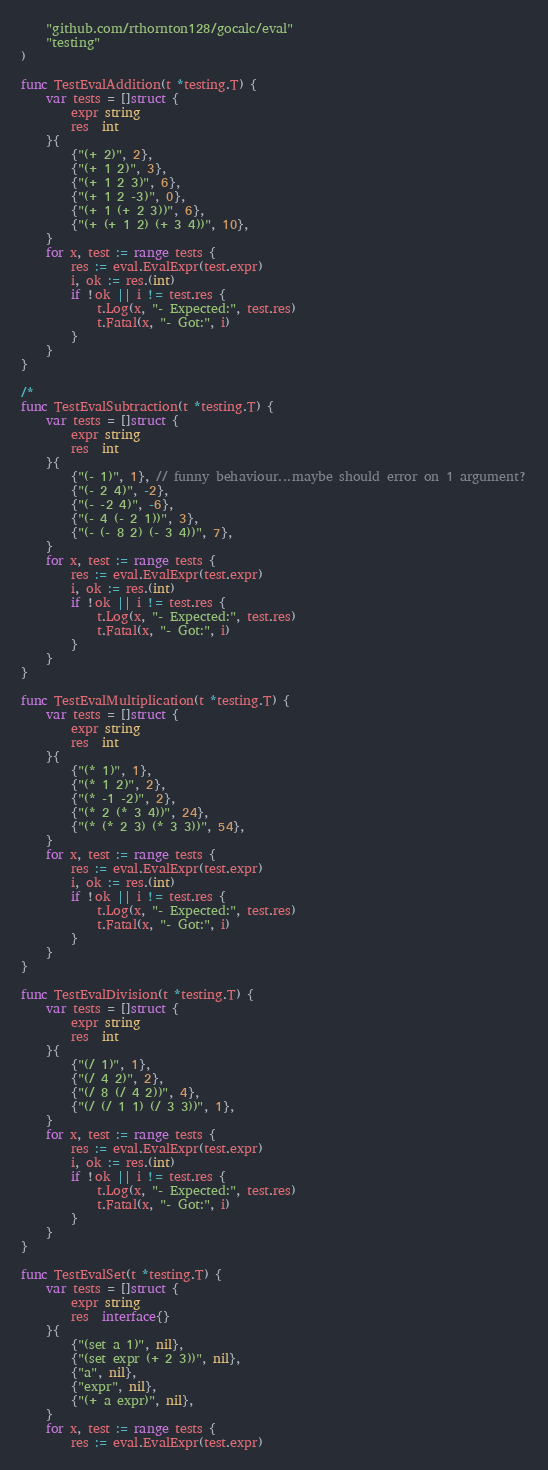<code> <loc_0><loc_0><loc_500><loc_500><_Go_>	"github.com/rthornton128/gocalc/eval"
	"testing"
)

func TestEvalAddition(t *testing.T) {
	var tests = []struct {
		expr string
		res  int
	}{
		{"(+ 2)", 2},
		{"(+ 1 2)", 3},
		{"(+ 1 2 3)", 6},
		{"(+ 1 2 -3)", 0},
		{"(+ 1 (+ 2 3))", 6},
		{"(+ (+ 1 2) (+ 3 4))", 10},
	}
	for x, test := range tests {
		res := eval.EvalExpr(test.expr)
		i, ok := res.(int)
		if !ok || i != test.res {
			t.Log(x, "- Expected:", test.res)
			t.Fatal(x, "- Got:", i)
		}
	}
}

/*
func TestEvalSubtraction(t *testing.T) {
	var tests = []struct {
		expr string
		res  int
	}{
		{"(- 1)", 1}, // funny behaviour...maybe should error on 1 argument?
		{"(- 2 4)", -2},
		{"(- -2 4)", -6},
		{"(- 4 (- 2 1))", 3},
		{"(- (- 8 2) (- 3 4))", 7},
	}
	for x, test := range tests {
		res := eval.EvalExpr(test.expr)
		i, ok := res.(int)
		if !ok || i != test.res {
			t.Log(x, "- Expected:", test.res)
			t.Fatal(x, "- Got:", i)
		}
	}
}

func TestEvalMultiplication(t *testing.T) {
	var tests = []struct {
		expr string
		res  int
	}{
		{"(* 1)", 1},
		{"(* 1 2)", 2},
		{"(* -1 -2)", 2},
		{"(* 2 (* 3 4))", 24},
		{"(* (* 2 3) (* 3 3))", 54},
	}
	for x, test := range tests {
		res := eval.EvalExpr(test.expr)
		i, ok := res.(int)
		if !ok || i != test.res {
			t.Log(x, "- Expected:", test.res)
			t.Fatal(x, "- Got:", i)
		}
	}
}

func TestEvalDivision(t *testing.T) {
	var tests = []struct {
		expr string
		res  int
	}{
		{"(/ 1)", 1},
		{"(/ 4 2)", 2},
		{"(/ 8 (/ 4 2))", 4},
		{"(/ (/ 1 1) (/ 3 3))", 1},
	}
	for x, test := range tests {
		res := eval.EvalExpr(test.expr)
		i, ok := res.(int)
		if !ok || i != test.res {
			t.Log(x, "- Expected:", test.res)
			t.Fatal(x, "- Got:", i)
		}
	}
}

func TestEvalSet(t *testing.T) {
	var tests = []struct {
		expr string
		res  interface{}
	}{
		{"(set a 1)", nil},
		{"(set expr (+ 2 3))", nil},
		{"a", nil},
		{"expr", nil},
		{"(+ a expr)", nil},
	}
	for x, test := range tests {
		res := eval.EvalExpr(test.expr)</code> 